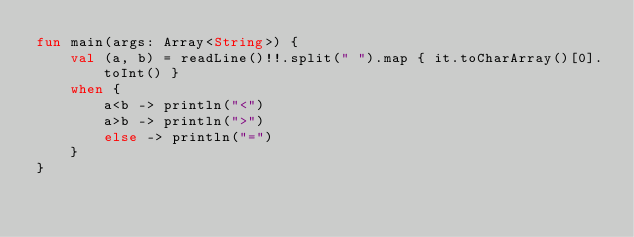Convert code to text. <code><loc_0><loc_0><loc_500><loc_500><_Kotlin_>fun main(args: Array<String>) {
    val (a, b) = readLine()!!.split(" ").map { it.toCharArray()[0].toInt() }
    when {
        a<b -> println("<")
        a>b -> println(">")
        else -> println("=")
    }
}</code> 